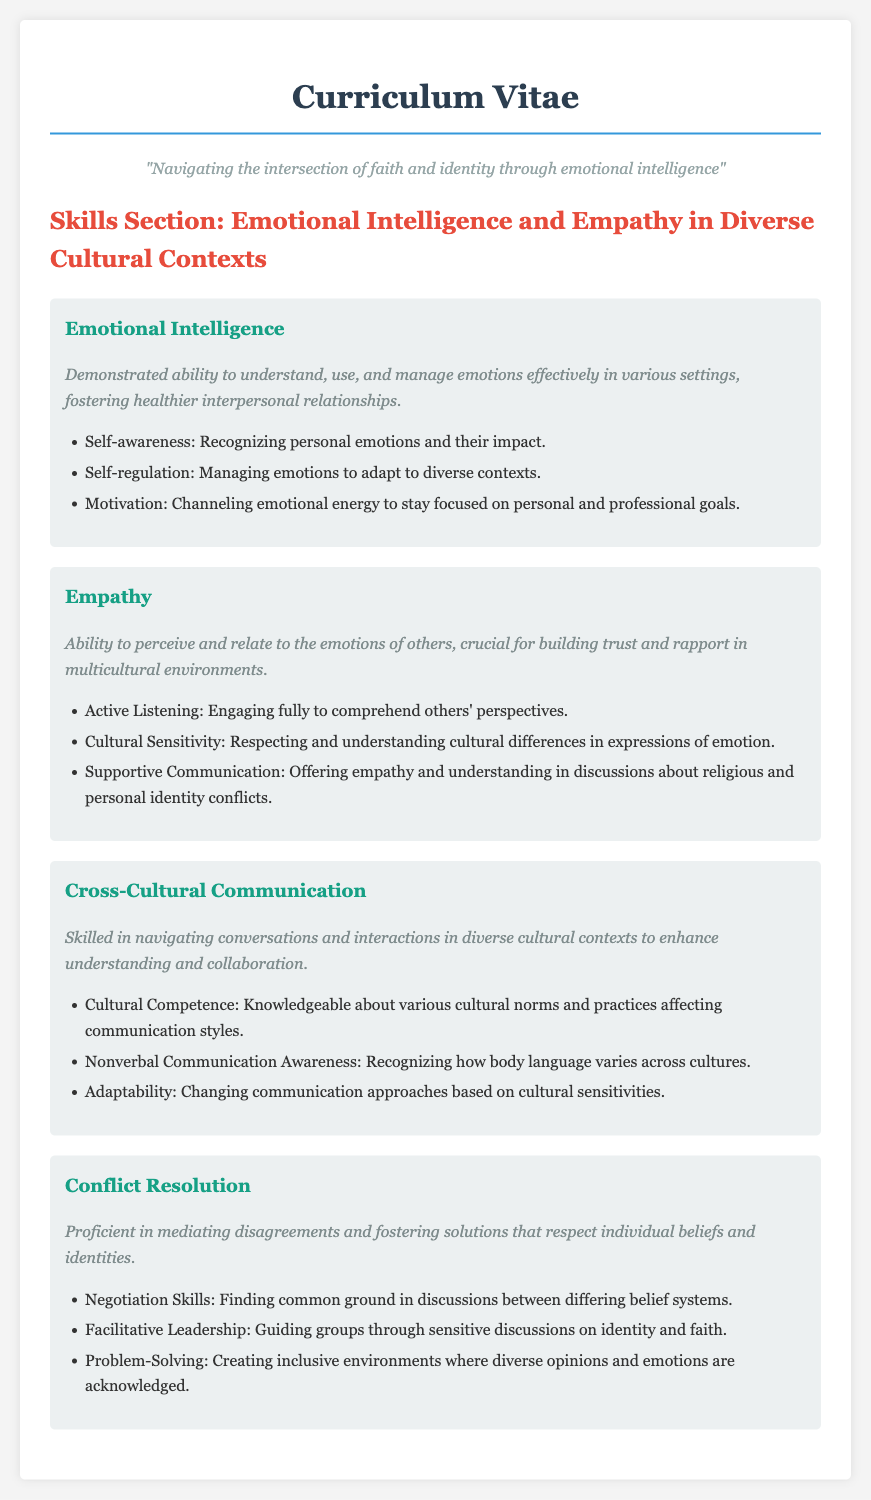what is the title of this document? The title of the document is presented prominently at the top, stating the purpose of the document.
Answer: Curriculum Vitae - Emotional Intelligence and Empathy how many skills are listed in the document? The document lists a total of four skills under the Skills Section.
Answer: four what ability is crucial for building trust in multicultural environments? The document specifies an ability that helps establish strong relationships with others in diverse contexts.
Answer: Empathy what is one component of emotional intelligence mentioned? The document details specific aspects of emotional intelligence, one of which is explicitly stated.
Answer: Self-awareness what type of communication is emphasized in the skills section? The title of the skills section describes the focus of discussion and interaction among diverse cultural backgrounds.
Answer: Cross-Cultural Communication how is supportive communication described? The document presents supportive communication as a specific way to engage in discussions about certain personal challenges, highlighting its importance.
Answer: Offering empathy and understanding in discussions about religious and personal identity conflicts which skill involves guiding groups through sensitive discussions? The document outlines a specific skill related to leadership and conflict mediation in the context of varying beliefs.
Answer: Facilitative Leadership what color is used for the main skill headings? The document uses a specific color for emphasis on the headings of each skill, making them stand out clearly.
Answer: #16a085 